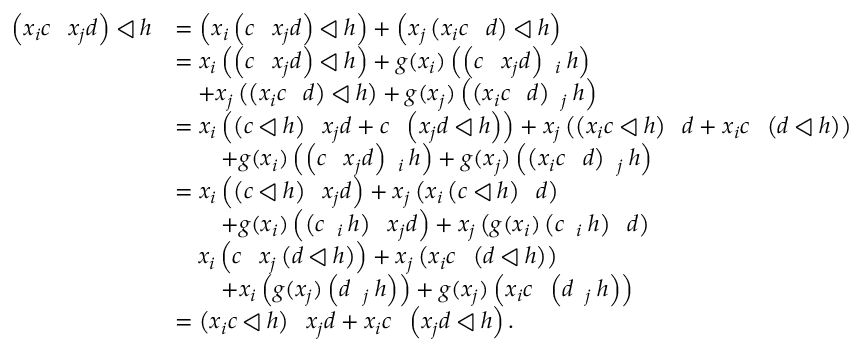<formula> <loc_0><loc_0><loc_500><loc_500>\begin{array} { r l } { \left ( x _ { i } c \ s h u f f l e x _ { j } d \right ) \triangleleft h } & { = \left ( x _ { i } \left ( c \ s h u f f l e x _ { j } d \right ) \triangleleft h \right ) + \left ( x _ { j } \left ( x _ { i } c \ s h u f f l e d \right ) \triangleleft h \right ) } \\ & { = x _ { i } \left ( \left ( c \ s h u f f l e x _ { j } d \right ) \triangleleft h \right ) + g ( x _ { i } ) \left ( \left ( c \ s h u f f l e x _ { j } d \right ) \ s h u f f l e _ { i } h \right ) } \\ & { \quad + x _ { j } \left ( \left ( x _ { i } c \ s h u f f l e d \right ) \triangleleft h \right ) + g ( x _ { j } ) \left ( \left ( x _ { i } c \ s h u f f l e d \right ) \ s h u f f l e _ { j } h \right ) } \\ & { = x _ { i } \left ( \left ( c \triangleleft h \right ) \ s h u f f l e x _ { j } d + c \ s h u f f l e \left ( x _ { j } d \triangleleft h \right ) \right ) + x _ { j } \left ( \left ( x _ { i } c \triangleleft h \right ) \ s h u f f l e d + x _ { i } c \ s h u f f l e \left ( d \triangleleft h \right ) \right ) } \\ & { \quad + g ( x _ { i } ) \left ( \left ( c \ s h u f f l e x _ { j } d \right ) \ s h u f f l e _ { i } h \right ) + g ( x _ { j } ) \left ( \left ( x _ { i } c \ s h u f f l e d \right ) \ s h u f f l e _ { j } h \right ) } \\ & { = x _ { i } \left ( \left ( c \triangleleft h \right ) \ s h u f f l e x _ { j } d \right ) + x _ { j } \left ( x _ { i } \left ( c \triangleleft h \right ) \ s h u f f l e d \right ) } \\ & { \quad + g ( x _ { i } ) \left ( \left ( c \ s h u f f l e _ { i } h \right ) \ s h u f f l e x _ { j } d \right ) + x _ { j } \left ( g ( x _ { i } ) \left ( c \ s h u f f l e _ { i } h \right ) \ s h u f f l e d \right ) } \\ & { \quad x _ { i } \left ( c \ s h u f f l e x _ { j } \left ( d \triangleleft h \right ) \right ) + x _ { j } \left ( x _ { i } c \ s h u f f l e \left ( d \triangleleft h \right ) \right ) } \\ & { \quad + x _ { i } \left ( g ( x _ { j } ) \left ( d \ s h u f f l e _ { j } h \right ) \right ) + g ( x _ { j } ) \left ( x _ { i } c \ s h u f f l e \left ( d \ s h u f f l e _ { j } h \right ) \right ) } \\ & { = \left ( x _ { i } c \triangleleft h \right ) \ s h u f f l e x _ { j } d + x _ { i } c \ s h u f f l e \left ( x _ { j } d \triangleleft h \right ) . } \end{array}</formula> 